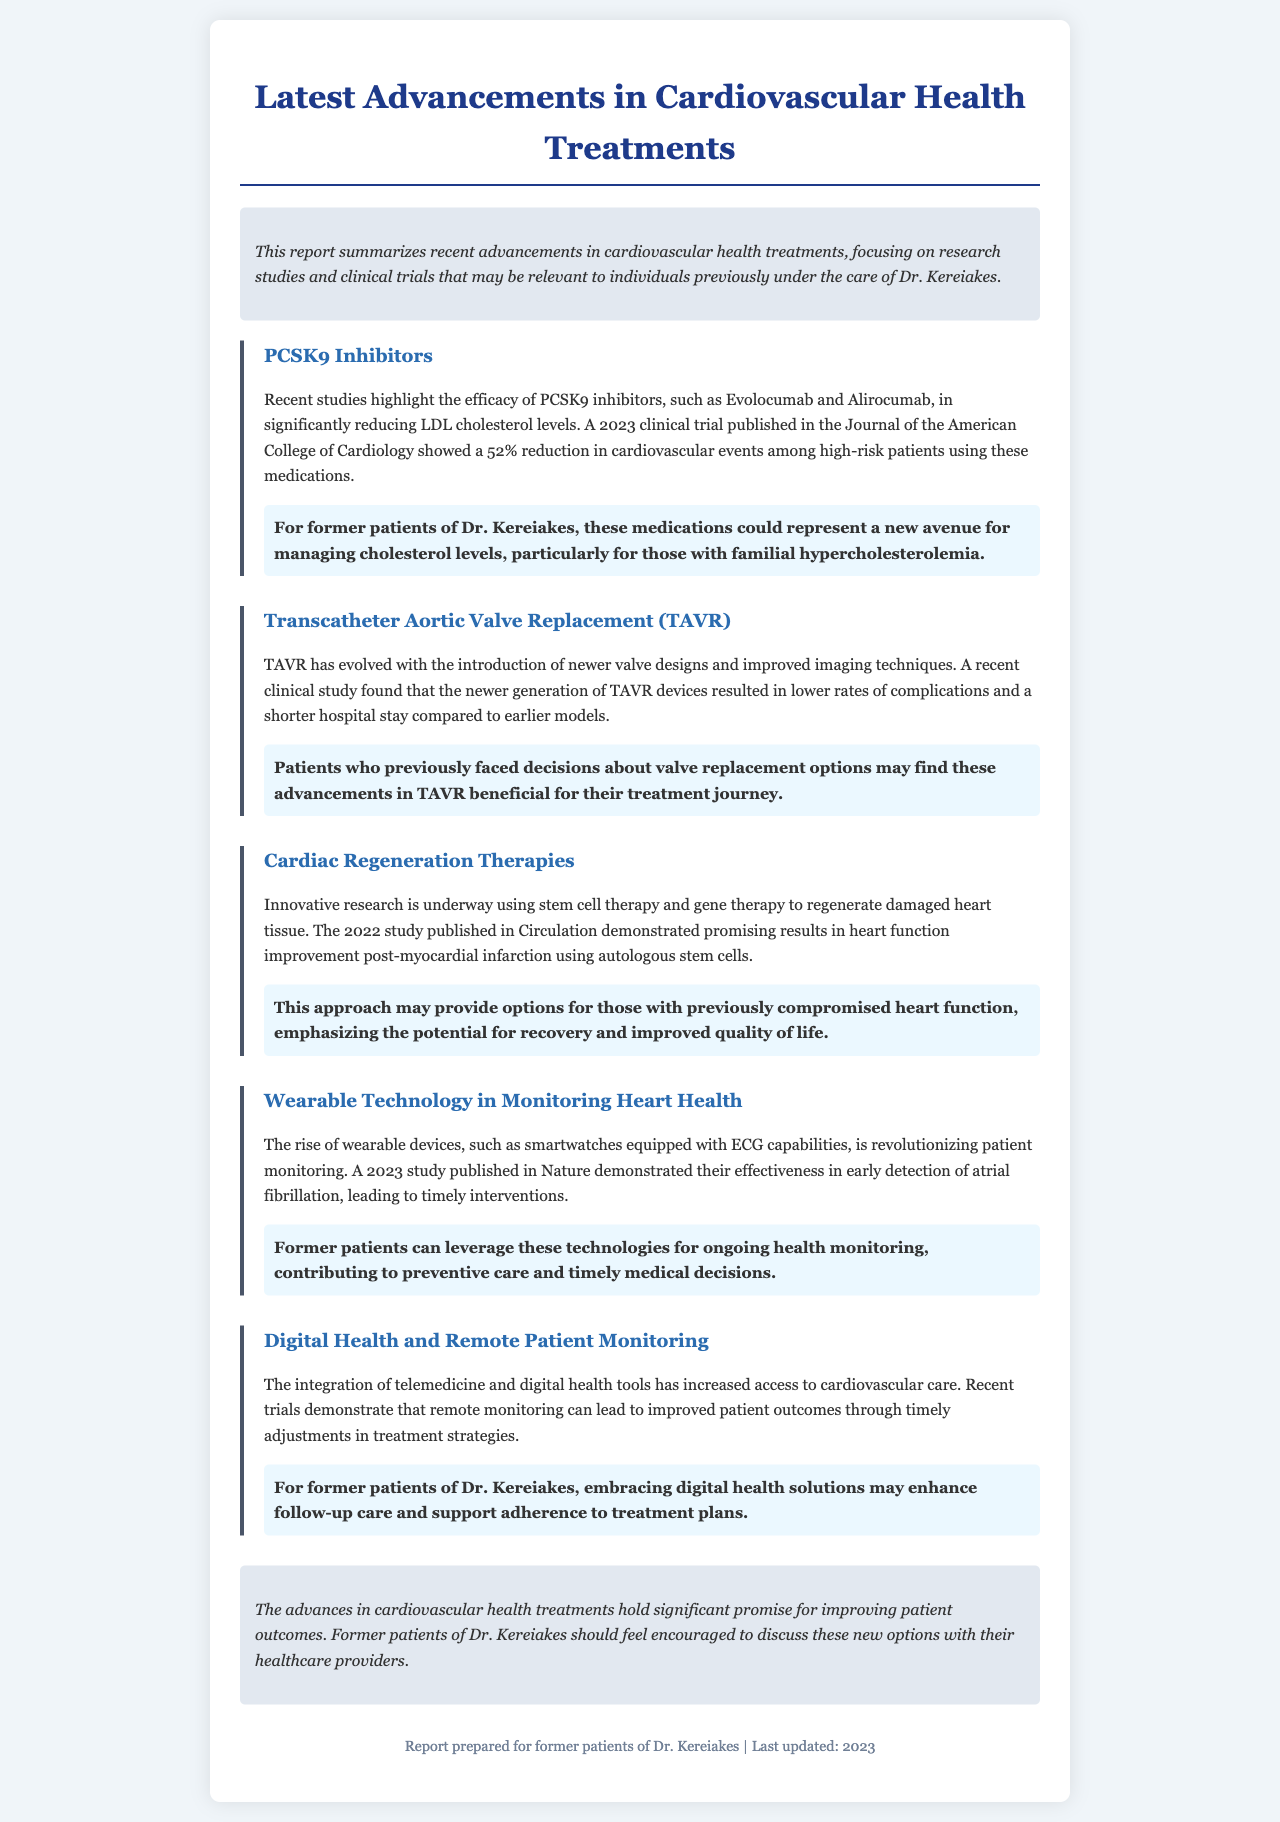What are PCSK9 inhibitors? PCSK9 inhibitors are medications such as Evolocumab and Alirocumab that reduce LDL cholesterol levels.
Answer: PCSK9 inhibitors What percentage reduction in cardiovascular events was found in a 2023 study? The study showed a 52% reduction in cardiovascular events among high-risk patients using PCSK9 inhibitors.
Answer: 52% What is TAVR? TAVR stands for Transcatheter Aortic Valve Replacement.
Answer: Transcatheter Aortic Valve Replacement What year was the study on cardiac regeneration therapies published? The study on cardiac regeneration therapies was published in 2022.
Answer: 2022 What benefit do wearable devices provide in heart health monitoring? Wearable devices enable early detection of atrial fibrillation, leading to timely interventions.
Answer: Early detection of atrial fibrillation What is one potential option mentioned for those with previously compromised heart function? Autologous stem cell therapy is a potential option for improving heart function after myocardial infarction.
Answer: Autologous stem cells Which publication detailed the rise of wearable technology in monitoring health? The research was published in Nature in 2023.
Answer: Nature What is emphasized for former patients of Dr. Kereiakes regarding new treatment options? They should feel encouraged to discuss new options with their healthcare providers.
Answer: Discuss new options with healthcare providers 